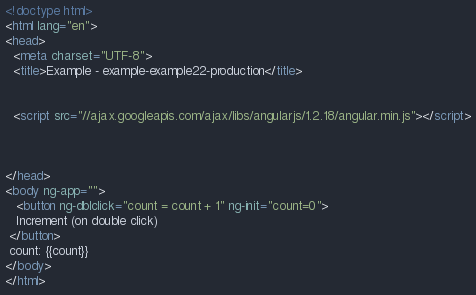<code> <loc_0><loc_0><loc_500><loc_500><_HTML_><!doctype html>
<html lang="en">
<head>
  <meta charset="UTF-8">
  <title>Example - example-example22-production</title>
  

  <script src="//ajax.googleapis.com/ajax/libs/angularjs/1.2.18/angular.min.js"></script>
  

  
</head>
<body ng-app="">
   <button ng-dblclick="count = count + 1" ng-init="count=0">
   Increment (on double click)
 </button>
 count: {{count}}
</body>
</html></code> 